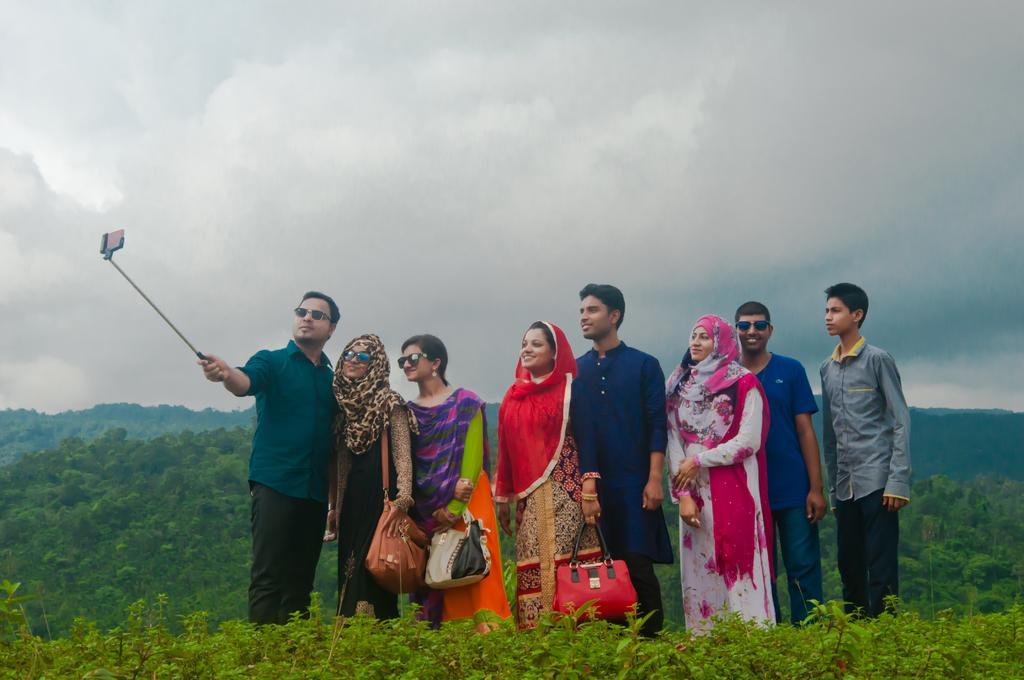How would you summarize this image in a sentence or two? In front of the image there are plants. There is a person holding the selfie stick. Beside him there are a few other people standing. In the background of the image there are trees. At the top of the image there are clouds in the sky. 